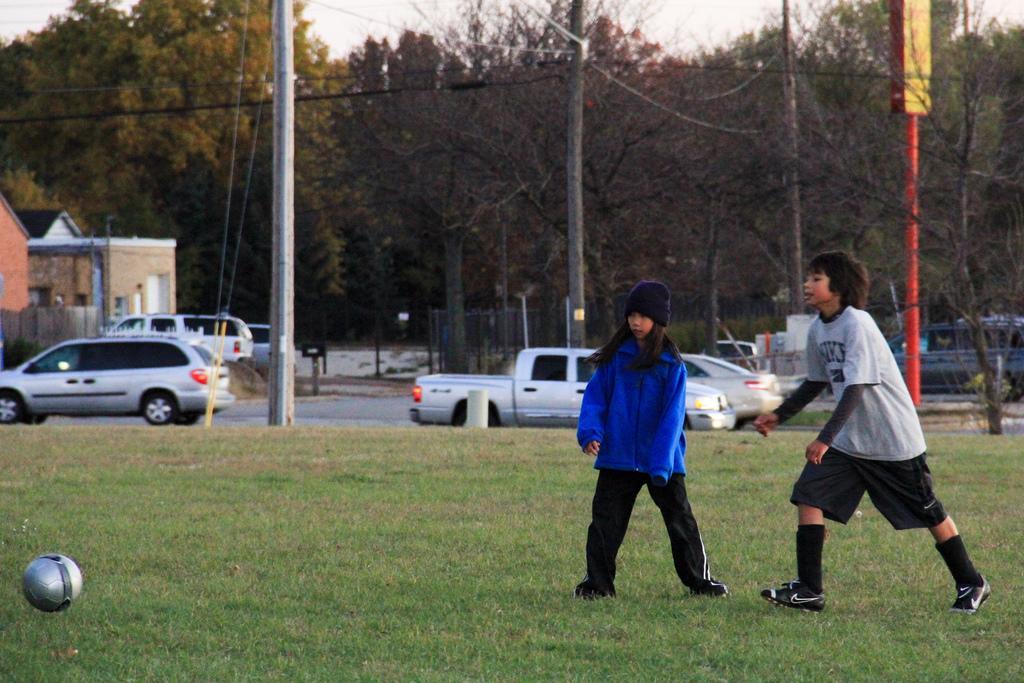Please provide a concise description of this image. In this picture I can see there are two kids playing, there is grass on the floor, there is a ball on the left side and there are few electric poles in the backdrop and there are fewer wires. There is a road and I can see there are few vehicles moving on the road, there are trees, a building on the left side and the sky is clear. 